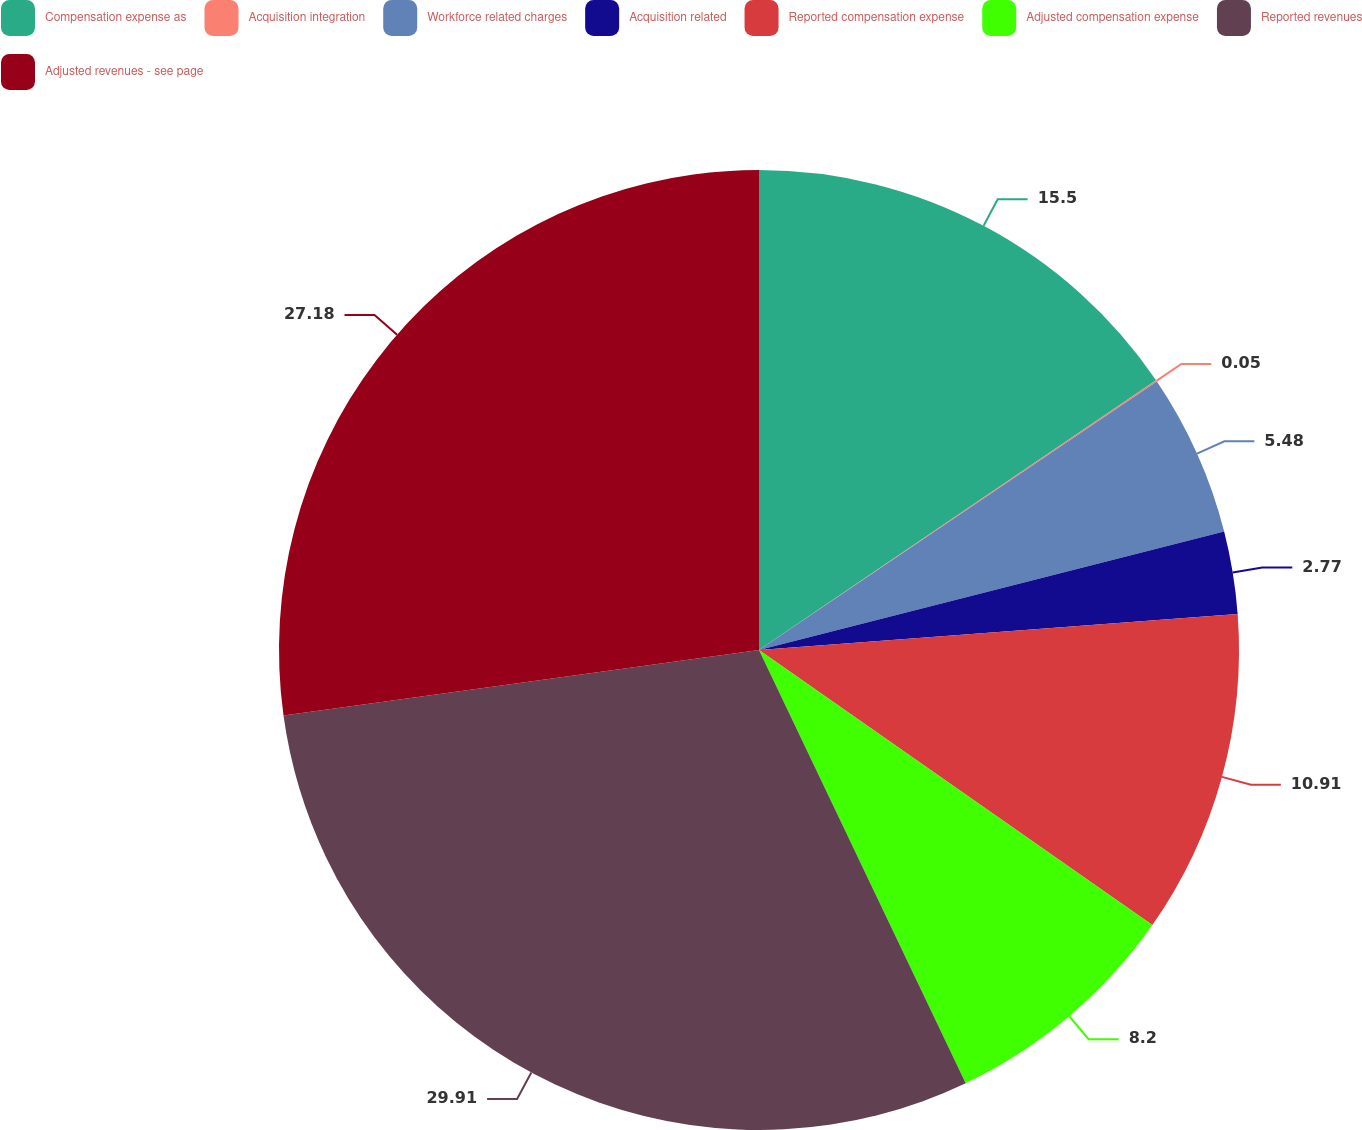Convert chart. <chart><loc_0><loc_0><loc_500><loc_500><pie_chart><fcel>Compensation expense as<fcel>Acquisition integration<fcel>Workforce related charges<fcel>Acquisition related<fcel>Reported compensation expense<fcel>Adjusted compensation expense<fcel>Reported revenues<fcel>Adjusted revenues - see page<nl><fcel>15.5%<fcel>0.05%<fcel>5.48%<fcel>2.77%<fcel>10.91%<fcel>8.2%<fcel>29.9%<fcel>27.18%<nl></chart> 